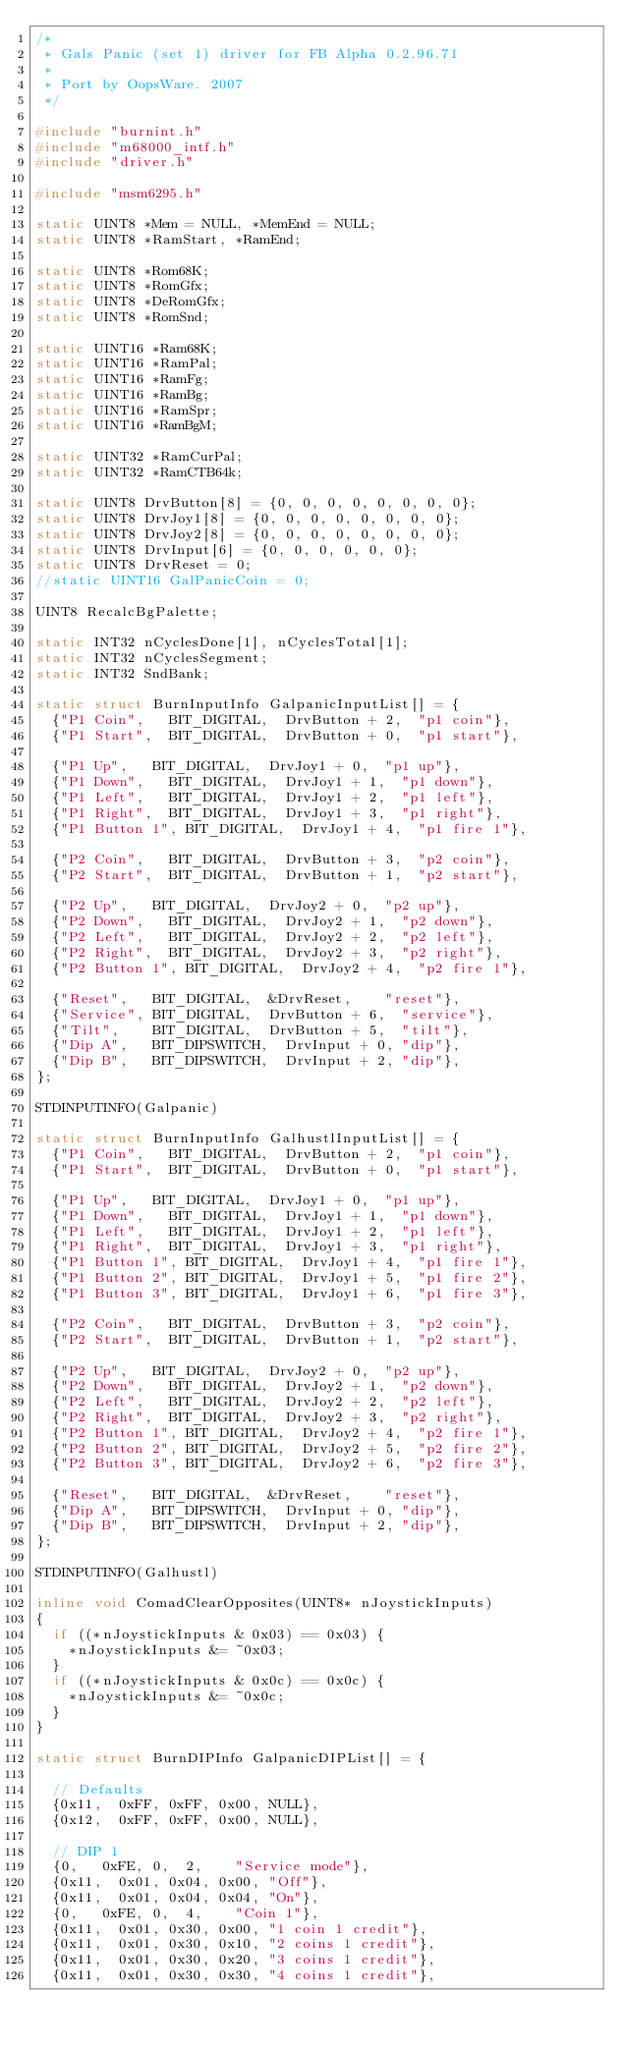<code> <loc_0><loc_0><loc_500><loc_500><_C++_>/*
 * Gals Panic (set 1) driver for FB Alpha 0.2.96.71
 *
 * Port by OopsWare. 2007
 */

#include "burnint.h"
#include "m68000_intf.h"
#include "driver.h"

#include "msm6295.h"

static UINT8 *Mem = NULL, *MemEnd = NULL;
static UINT8 *RamStart, *RamEnd;

static UINT8 *Rom68K;
static UINT8 *RomGfx;
static UINT8 *DeRomGfx;
static UINT8 *RomSnd;

static UINT16 *Ram68K;
static UINT16 *RamPal;
static UINT16 *RamFg;
static UINT16 *RamBg;
static UINT16 *RamSpr;
static UINT16 *RamBgM;

static UINT32 *RamCurPal;
static UINT32 *RamCTB64k;

static UINT8 DrvButton[8] = {0, 0, 0, 0, 0, 0, 0, 0};
static UINT8 DrvJoy1[8] = {0, 0, 0, 0, 0, 0, 0, 0};
static UINT8 DrvJoy2[8] = {0, 0, 0, 0, 0, 0, 0, 0};
static UINT8 DrvInput[6] = {0, 0, 0, 0, 0, 0};
static UINT8 DrvReset = 0;
//static UINT16 GalPanicCoin = 0;

UINT8 RecalcBgPalette;

static INT32 nCyclesDone[1], nCyclesTotal[1];
static INT32 nCyclesSegment;
static INT32 SndBank;

static struct BurnInputInfo GalpanicInputList[] = {
	{"P1 Coin",		BIT_DIGITAL,	DrvButton + 2,	"p1 coin"},
	{"P1 Start",	BIT_DIGITAL,	DrvButton + 0,	"p1 start"},

	{"P1 Up",		BIT_DIGITAL,	DrvJoy1 + 0,	"p1 up"},
	{"P1 Down",		BIT_DIGITAL,	DrvJoy1 + 1,	"p1 down"},
	{"P1 Left",		BIT_DIGITAL,	DrvJoy1 + 2,	"p1 left"},
	{"P1 Right",	BIT_DIGITAL,	DrvJoy1 + 3,	"p1 right"},
	{"P1 Button 1",	BIT_DIGITAL,	DrvJoy1 + 4,	"p1 fire 1"},

	{"P2 Coin",		BIT_DIGITAL,	DrvButton + 3,	"p2 coin"},
	{"P2 Start",	BIT_DIGITAL,	DrvButton + 1,	"p2 start"},

	{"P2 Up",		BIT_DIGITAL,	DrvJoy2 + 0,	"p2 up"},
	{"P2 Down",		BIT_DIGITAL,	DrvJoy2 + 1,	"p2 down"},
	{"P2 Left",		BIT_DIGITAL,	DrvJoy2 + 2,	"p2 left"},
	{"P2 Right",	BIT_DIGITAL,	DrvJoy2 + 3,	"p2 right"},
	{"P2 Button 1",	BIT_DIGITAL,	DrvJoy2 + 4,	"p2 fire 1"},

	{"Reset",		BIT_DIGITAL,	&DrvReset,		"reset"},
	{"Service",	BIT_DIGITAL,	DrvButton + 6,	"service"},
	{"Tilt",	  BIT_DIGITAL,	DrvButton + 5,	"tilt"},
	{"Dip A",		BIT_DIPSWITCH,	DrvInput + 0,	"dip"},
	{"Dip B",		BIT_DIPSWITCH,	DrvInput + 2,	"dip"},
};

STDINPUTINFO(Galpanic)

static struct BurnInputInfo GalhustlInputList[] = {
	{"P1 Coin",		BIT_DIGITAL,	DrvButton + 2,	"p1 coin"},
	{"P1 Start",	BIT_DIGITAL,	DrvButton + 0,	"p1 start"},

	{"P1 Up",		BIT_DIGITAL,	DrvJoy1 + 0,	"p1 up"},
	{"P1 Down",		BIT_DIGITAL,	DrvJoy1 + 1,	"p1 down"},
	{"P1 Left",		BIT_DIGITAL,	DrvJoy1 + 2,	"p1 left"},
	{"P1 Right",	BIT_DIGITAL,	DrvJoy1 + 3,	"p1 right"},
	{"P1 Button 1",	BIT_DIGITAL,	DrvJoy1 + 4,	"p1 fire 1"},
	{"P1 Button 2",	BIT_DIGITAL,	DrvJoy1 + 5,	"p1 fire 2"},
	{"P1 Button 3",	BIT_DIGITAL,	DrvJoy1 + 6,	"p1 fire 3"},

	{"P2 Coin",		BIT_DIGITAL,	DrvButton + 3,	"p2 coin"},
	{"P2 Start",	BIT_DIGITAL,	DrvButton + 1,	"p2 start"},

	{"P2 Up",		BIT_DIGITAL,	DrvJoy2 + 0,	"p2 up"},
	{"P2 Down",		BIT_DIGITAL,	DrvJoy2 + 1,	"p2 down"},
	{"P2 Left",		BIT_DIGITAL,	DrvJoy2 + 2,	"p2 left"},
	{"P2 Right",	BIT_DIGITAL,	DrvJoy2 + 3,	"p2 right"},
	{"P2 Button 1",	BIT_DIGITAL,	DrvJoy2 + 4,	"p2 fire 1"},
	{"P2 Button 2",	BIT_DIGITAL,	DrvJoy2 + 5,	"p2 fire 2"},
	{"P2 Button 3",	BIT_DIGITAL,	DrvJoy2 + 6,	"p2 fire 3"},

	{"Reset",		BIT_DIGITAL,	&DrvReset,		"reset"},
	{"Dip A",		BIT_DIPSWITCH,	DrvInput + 0,	"dip"},
	{"Dip B",		BIT_DIPSWITCH,	DrvInput + 2,	"dip"},
};

STDINPUTINFO(Galhustl)

inline void ComadClearOpposites(UINT8* nJoystickInputs)
{
	if ((*nJoystickInputs & 0x03) == 0x03) {
		*nJoystickInputs &= ~0x03;
	}
	if ((*nJoystickInputs & 0x0c) == 0x0c) {
		*nJoystickInputs &= ~0x0c;
	}
}

static struct BurnDIPInfo GalpanicDIPList[] = {

	// Defaults
	{0x11,	0xFF, 0xFF,	0x00, NULL},
	{0x12,	0xFF, 0xFF,	0x00, NULL},

	// DIP 1
	{0,		0xFE, 0,	2,	  "Service mode"},
	{0x11,	0x01, 0x04, 0x00, "Off"},
	{0x11,	0x01, 0x04, 0x04, "On"},
	{0,		0xFE, 0,	4,	  "Coin 1"},
	{0x11,	0x01, 0x30, 0x00, "1 coin 1 credit"},
	{0x11,	0x01, 0x30, 0x10, "2 coins 1 credit"},
	{0x11,	0x01, 0x30, 0x20, "3 coins 1 credit"},
	{0x11,	0x01, 0x30, 0x30, "4 coins 1 credit"},</code> 